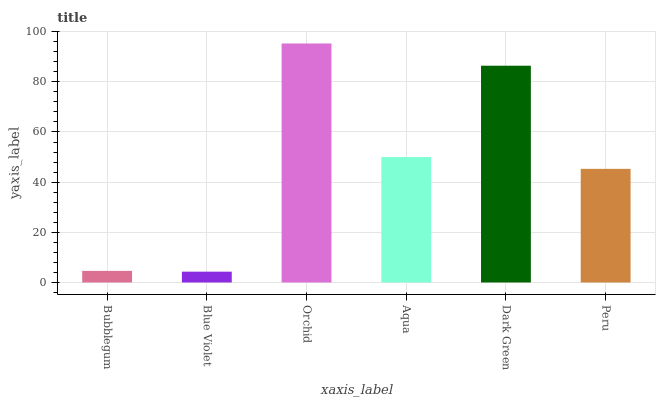Is Blue Violet the minimum?
Answer yes or no. Yes. Is Orchid the maximum?
Answer yes or no. Yes. Is Orchid the minimum?
Answer yes or no. No. Is Blue Violet the maximum?
Answer yes or no. No. Is Orchid greater than Blue Violet?
Answer yes or no. Yes. Is Blue Violet less than Orchid?
Answer yes or no. Yes. Is Blue Violet greater than Orchid?
Answer yes or no. No. Is Orchid less than Blue Violet?
Answer yes or no. No. Is Aqua the high median?
Answer yes or no. Yes. Is Peru the low median?
Answer yes or no. Yes. Is Orchid the high median?
Answer yes or no. No. Is Orchid the low median?
Answer yes or no. No. 